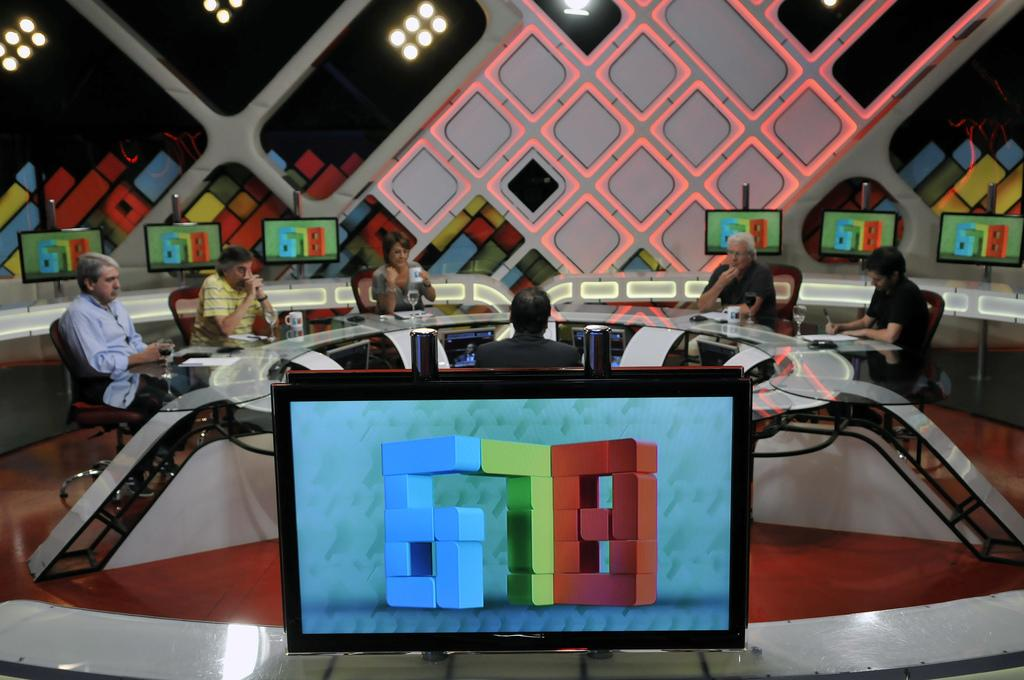<image>
Write a terse but informative summary of the picture. People are gathered around a table while several televisions display the numbers 6 7 8 